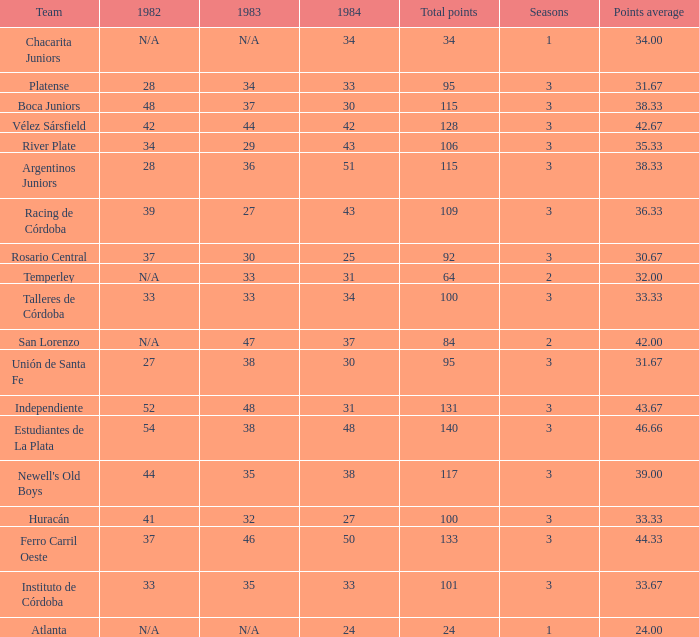What is the points total for the team with points average more than 34, 1984 score more than 37 and N/A in 1982? 0.0. 